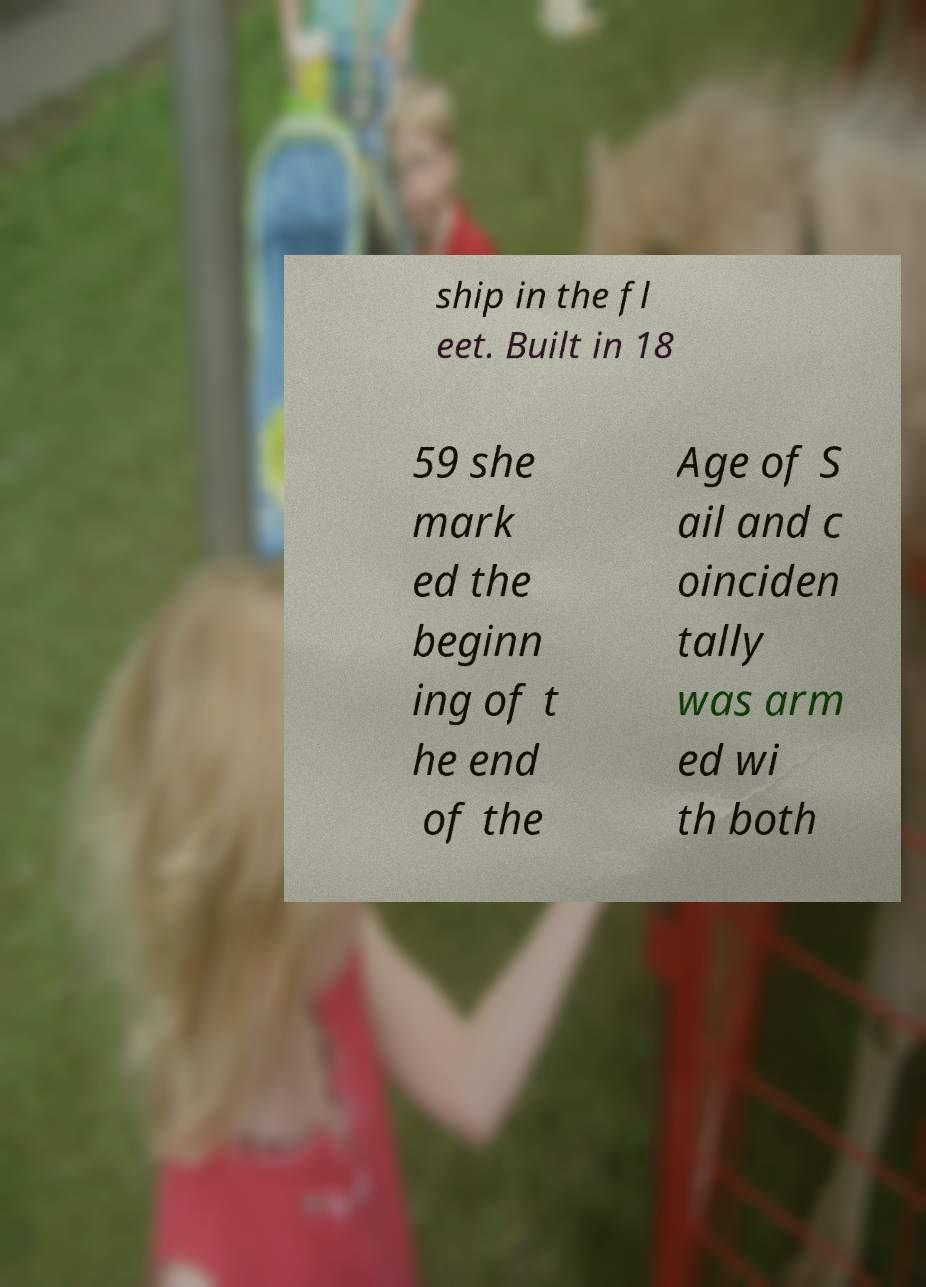There's text embedded in this image that I need extracted. Can you transcribe it verbatim? ship in the fl eet. Built in 18 59 she mark ed the beginn ing of t he end of the Age of S ail and c oinciden tally was arm ed wi th both 